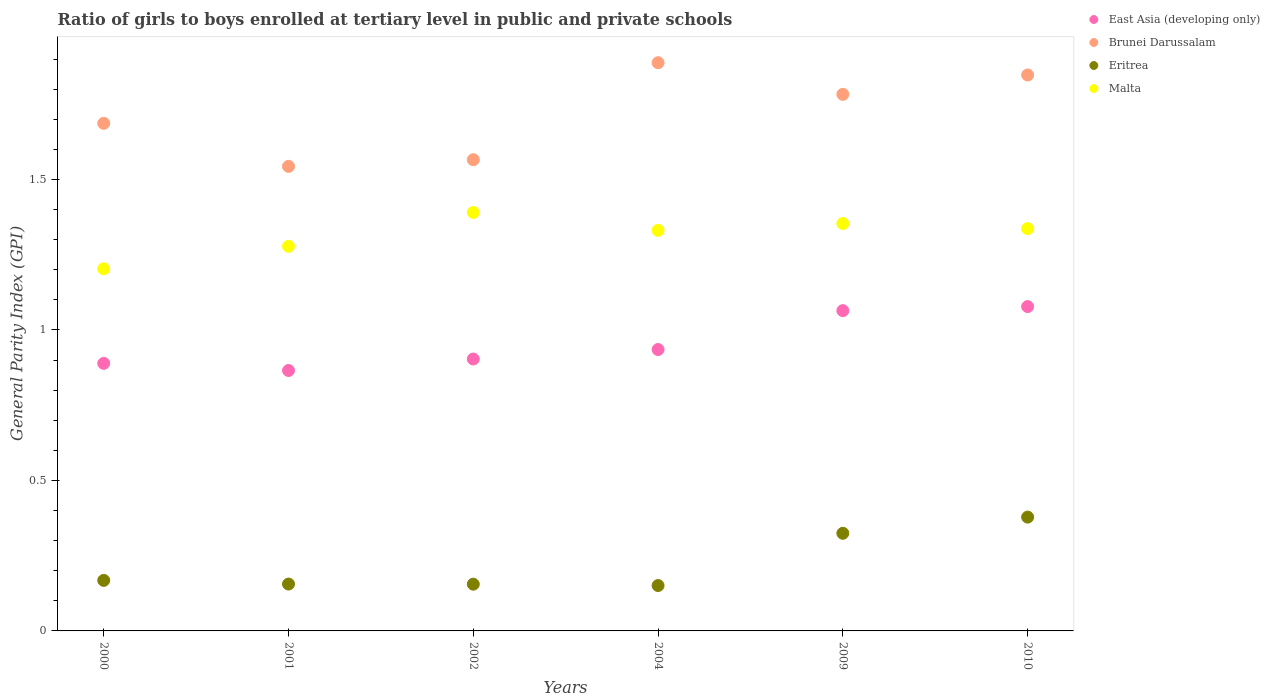Is the number of dotlines equal to the number of legend labels?
Keep it short and to the point. Yes. What is the general parity index in Brunei Darussalam in 2002?
Offer a terse response. 1.57. Across all years, what is the maximum general parity index in Malta?
Ensure brevity in your answer.  1.39. Across all years, what is the minimum general parity index in East Asia (developing only)?
Offer a very short reply. 0.87. In which year was the general parity index in Eritrea maximum?
Keep it short and to the point. 2010. What is the total general parity index in Malta in the graph?
Offer a very short reply. 7.89. What is the difference between the general parity index in Brunei Darussalam in 2001 and that in 2002?
Offer a very short reply. -0.02. What is the difference between the general parity index in East Asia (developing only) in 2002 and the general parity index in Eritrea in 2009?
Provide a succinct answer. 0.58. What is the average general parity index in Brunei Darussalam per year?
Offer a terse response. 1.72. In the year 2002, what is the difference between the general parity index in Brunei Darussalam and general parity index in Malta?
Keep it short and to the point. 0.18. In how many years, is the general parity index in East Asia (developing only) greater than 0.4?
Provide a succinct answer. 6. What is the ratio of the general parity index in Eritrea in 2004 to that in 2010?
Make the answer very short. 0.4. Is the difference between the general parity index in Brunei Darussalam in 2002 and 2004 greater than the difference between the general parity index in Malta in 2002 and 2004?
Keep it short and to the point. No. What is the difference between the highest and the second highest general parity index in Brunei Darussalam?
Your response must be concise. 0.04. What is the difference between the highest and the lowest general parity index in Malta?
Your answer should be very brief. 0.19. How many dotlines are there?
Your answer should be compact. 4. Does the graph contain grids?
Provide a short and direct response. No. What is the title of the graph?
Your answer should be compact. Ratio of girls to boys enrolled at tertiary level in public and private schools. What is the label or title of the Y-axis?
Your answer should be very brief. General Parity Index (GPI). What is the General Parity Index (GPI) of East Asia (developing only) in 2000?
Provide a succinct answer. 0.89. What is the General Parity Index (GPI) in Brunei Darussalam in 2000?
Keep it short and to the point. 1.69. What is the General Parity Index (GPI) of Eritrea in 2000?
Give a very brief answer. 0.17. What is the General Parity Index (GPI) of Malta in 2000?
Make the answer very short. 1.2. What is the General Parity Index (GPI) in East Asia (developing only) in 2001?
Keep it short and to the point. 0.87. What is the General Parity Index (GPI) in Brunei Darussalam in 2001?
Give a very brief answer. 1.54. What is the General Parity Index (GPI) of Eritrea in 2001?
Give a very brief answer. 0.16. What is the General Parity Index (GPI) of Malta in 2001?
Your response must be concise. 1.28. What is the General Parity Index (GPI) of East Asia (developing only) in 2002?
Your answer should be very brief. 0.9. What is the General Parity Index (GPI) in Brunei Darussalam in 2002?
Make the answer very short. 1.57. What is the General Parity Index (GPI) of Eritrea in 2002?
Offer a terse response. 0.16. What is the General Parity Index (GPI) in Malta in 2002?
Offer a terse response. 1.39. What is the General Parity Index (GPI) of East Asia (developing only) in 2004?
Your answer should be compact. 0.94. What is the General Parity Index (GPI) of Brunei Darussalam in 2004?
Make the answer very short. 1.89. What is the General Parity Index (GPI) of Eritrea in 2004?
Offer a terse response. 0.15. What is the General Parity Index (GPI) of Malta in 2004?
Your answer should be very brief. 1.33. What is the General Parity Index (GPI) in East Asia (developing only) in 2009?
Provide a short and direct response. 1.06. What is the General Parity Index (GPI) in Brunei Darussalam in 2009?
Provide a short and direct response. 1.78. What is the General Parity Index (GPI) of Eritrea in 2009?
Keep it short and to the point. 0.32. What is the General Parity Index (GPI) in Malta in 2009?
Make the answer very short. 1.35. What is the General Parity Index (GPI) in East Asia (developing only) in 2010?
Your answer should be very brief. 1.08. What is the General Parity Index (GPI) in Brunei Darussalam in 2010?
Your response must be concise. 1.85. What is the General Parity Index (GPI) of Eritrea in 2010?
Offer a terse response. 0.38. What is the General Parity Index (GPI) in Malta in 2010?
Offer a very short reply. 1.34. Across all years, what is the maximum General Parity Index (GPI) in East Asia (developing only)?
Your answer should be compact. 1.08. Across all years, what is the maximum General Parity Index (GPI) in Brunei Darussalam?
Keep it short and to the point. 1.89. Across all years, what is the maximum General Parity Index (GPI) of Eritrea?
Provide a short and direct response. 0.38. Across all years, what is the maximum General Parity Index (GPI) of Malta?
Keep it short and to the point. 1.39. Across all years, what is the minimum General Parity Index (GPI) of East Asia (developing only)?
Your answer should be compact. 0.87. Across all years, what is the minimum General Parity Index (GPI) in Brunei Darussalam?
Give a very brief answer. 1.54. Across all years, what is the minimum General Parity Index (GPI) of Eritrea?
Offer a very short reply. 0.15. Across all years, what is the minimum General Parity Index (GPI) in Malta?
Your answer should be very brief. 1.2. What is the total General Parity Index (GPI) in East Asia (developing only) in the graph?
Your response must be concise. 5.74. What is the total General Parity Index (GPI) of Brunei Darussalam in the graph?
Offer a very short reply. 10.32. What is the total General Parity Index (GPI) in Eritrea in the graph?
Your answer should be compact. 1.33. What is the total General Parity Index (GPI) of Malta in the graph?
Your answer should be compact. 7.89. What is the difference between the General Parity Index (GPI) of East Asia (developing only) in 2000 and that in 2001?
Make the answer very short. 0.02. What is the difference between the General Parity Index (GPI) of Brunei Darussalam in 2000 and that in 2001?
Offer a very short reply. 0.14. What is the difference between the General Parity Index (GPI) in Eritrea in 2000 and that in 2001?
Give a very brief answer. 0.01. What is the difference between the General Parity Index (GPI) in Malta in 2000 and that in 2001?
Make the answer very short. -0.07. What is the difference between the General Parity Index (GPI) of East Asia (developing only) in 2000 and that in 2002?
Provide a short and direct response. -0.01. What is the difference between the General Parity Index (GPI) of Brunei Darussalam in 2000 and that in 2002?
Your response must be concise. 0.12. What is the difference between the General Parity Index (GPI) of Eritrea in 2000 and that in 2002?
Provide a short and direct response. 0.01. What is the difference between the General Parity Index (GPI) in Malta in 2000 and that in 2002?
Ensure brevity in your answer.  -0.19. What is the difference between the General Parity Index (GPI) in East Asia (developing only) in 2000 and that in 2004?
Provide a succinct answer. -0.05. What is the difference between the General Parity Index (GPI) in Brunei Darussalam in 2000 and that in 2004?
Provide a short and direct response. -0.2. What is the difference between the General Parity Index (GPI) in Eritrea in 2000 and that in 2004?
Provide a short and direct response. 0.02. What is the difference between the General Parity Index (GPI) of Malta in 2000 and that in 2004?
Offer a terse response. -0.13. What is the difference between the General Parity Index (GPI) of East Asia (developing only) in 2000 and that in 2009?
Your answer should be very brief. -0.18. What is the difference between the General Parity Index (GPI) of Brunei Darussalam in 2000 and that in 2009?
Your answer should be very brief. -0.1. What is the difference between the General Parity Index (GPI) in Eritrea in 2000 and that in 2009?
Ensure brevity in your answer.  -0.16. What is the difference between the General Parity Index (GPI) of Malta in 2000 and that in 2009?
Give a very brief answer. -0.15. What is the difference between the General Parity Index (GPI) in East Asia (developing only) in 2000 and that in 2010?
Keep it short and to the point. -0.19. What is the difference between the General Parity Index (GPI) in Brunei Darussalam in 2000 and that in 2010?
Ensure brevity in your answer.  -0.16. What is the difference between the General Parity Index (GPI) in Eritrea in 2000 and that in 2010?
Your response must be concise. -0.21. What is the difference between the General Parity Index (GPI) in Malta in 2000 and that in 2010?
Offer a very short reply. -0.13. What is the difference between the General Parity Index (GPI) in East Asia (developing only) in 2001 and that in 2002?
Your response must be concise. -0.04. What is the difference between the General Parity Index (GPI) of Brunei Darussalam in 2001 and that in 2002?
Your answer should be very brief. -0.02. What is the difference between the General Parity Index (GPI) in Malta in 2001 and that in 2002?
Offer a terse response. -0.11. What is the difference between the General Parity Index (GPI) in East Asia (developing only) in 2001 and that in 2004?
Your response must be concise. -0.07. What is the difference between the General Parity Index (GPI) in Brunei Darussalam in 2001 and that in 2004?
Give a very brief answer. -0.34. What is the difference between the General Parity Index (GPI) in Eritrea in 2001 and that in 2004?
Offer a terse response. 0. What is the difference between the General Parity Index (GPI) in Malta in 2001 and that in 2004?
Keep it short and to the point. -0.05. What is the difference between the General Parity Index (GPI) in East Asia (developing only) in 2001 and that in 2009?
Provide a short and direct response. -0.2. What is the difference between the General Parity Index (GPI) in Brunei Darussalam in 2001 and that in 2009?
Provide a succinct answer. -0.24. What is the difference between the General Parity Index (GPI) of Eritrea in 2001 and that in 2009?
Your answer should be very brief. -0.17. What is the difference between the General Parity Index (GPI) of Malta in 2001 and that in 2009?
Provide a short and direct response. -0.08. What is the difference between the General Parity Index (GPI) of East Asia (developing only) in 2001 and that in 2010?
Your answer should be compact. -0.21. What is the difference between the General Parity Index (GPI) of Brunei Darussalam in 2001 and that in 2010?
Your answer should be compact. -0.3. What is the difference between the General Parity Index (GPI) in Eritrea in 2001 and that in 2010?
Provide a succinct answer. -0.22. What is the difference between the General Parity Index (GPI) of Malta in 2001 and that in 2010?
Your answer should be very brief. -0.06. What is the difference between the General Parity Index (GPI) of East Asia (developing only) in 2002 and that in 2004?
Keep it short and to the point. -0.03. What is the difference between the General Parity Index (GPI) in Brunei Darussalam in 2002 and that in 2004?
Provide a succinct answer. -0.32. What is the difference between the General Parity Index (GPI) in Eritrea in 2002 and that in 2004?
Your answer should be very brief. 0. What is the difference between the General Parity Index (GPI) of Malta in 2002 and that in 2004?
Your answer should be compact. 0.06. What is the difference between the General Parity Index (GPI) of East Asia (developing only) in 2002 and that in 2009?
Keep it short and to the point. -0.16. What is the difference between the General Parity Index (GPI) in Brunei Darussalam in 2002 and that in 2009?
Make the answer very short. -0.22. What is the difference between the General Parity Index (GPI) of Eritrea in 2002 and that in 2009?
Make the answer very short. -0.17. What is the difference between the General Parity Index (GPI) of Malta in 2002 and that in 2009?
Provide a short and direct response. 0.04. What is the difference between the General Parity Index (GPI) in East Asia (developing only) in 2002 and that in 2010?
Ensure brevity in your answer.  -0.17. What is the difference between the General Parity Index (GPI) of Brunei Darussalam in 2002 and that in 2010?
Provide a short and direct response. -0.28. What is the difference between the General Parity Index (GPI) in Eritrea in 2002 and that in 2010?
Your response must be concise. -0.22. What is the difference between the General Parity Index (GPI) in Malta in 2002 and that in 2010?
Give a very brief answer. 0.05. What is the difference between the General Parity Index (GPI) of East Asia (developing only) in 2004 and that in 2009?
Your answer should be very brief. -0.13. What is the difference between the General Parity Index (GPI) of Brunei Darussalam in 2004 and that in 2009?
Ensure brevity in your answer.  0.11. What is the difference between the General Parity Index (GPI) in Eritrea in 2004 and that in 2009?
Your answer should be very brief. -0.17. What is the difference between the General Parity Index (GPI) of Malta in 2004 and that in 2009?
Ensure brevity in your answer.  -0.02. What is the difference between the General Parity Index (GPI) of East Asia (developing only) in 2004 and that in 2010?
Your answer should be very brief. -0.14. What is the difference between the General Parity Index (GPI) in Brunei Darussalam in 2004 and that in 2010?
Your answer should be compact. 0.04. What is the difference between the General Parity Index (GPI) in Eritrea in 2004 and that in 2010?
Give a very brief answer. -0.23. What is the difference between the General Parity Index (GPI) of Malta in 2004 and that in 2010?
Make the answer very short. -0.01. What is the difference between the General Parity Index (GPI) in East Asia (developing only) in 2009 and that in 2010?
Ensure brevity in your answer.  -0.01. What is the difference between the General Parity Index (GPI) in Brunei Darussalam in 2009 and that in 2010?
Provide a succinct answer. -0.06. What is the difference between the General Parity Index (GPI) in Eritrea in 2009 and that in 2010?
Keep it short and to the point. -0.05. What is the difference between the General Parity Index (GPI) of Malta in 2009 and that in 2010?
Keep it short and to the point. 0.02. What is the difference between the General Parity Index (GPI) in East Asia (developing only) in 2000 and the General Parity Index (GPI) in Brunei Darussalam in 2001?
Provide a short and direct response. -0.65. What is the difference between the General Parity Index (GPI) in East Asia (developing only) in 2000 and the General Parity Index (GPI) in Eritrea in 2001?
Give a very brief answer. 0.73. What is the difference between the General Parity Index (GPI) in East Asia (developing only) in 2000 and the General Parity Index (GPI) in Malta in 2001?
Your response must be concise. -0.39. What is the difference between the General Parity Index (GPI) in Brunei Darussalam in 2000 and the General Parity Index (GPI) in Eritrea in 2001?
Provide a short and direct response. 1.53. What is the difference between the General Parity Index (GPI) in Brunei Darussalam in 2000 and the General Parity Index (GPI) in Malta in 2001?
Provide a short and direct response. 0.41. What is the difference between the General Parity Index (GPI) of Eritrea in 2000 and the General Parity Index (GPI) of Malta in 2001?
Your response must be concise. -1.11. What is the difference between the General Parity Index (GPI) of East Asia (developing only) in 2000 and the General Parity Index (GPI) of Brunei Darussalam in 2002?
Make the answer very short. -0.68. What is the difference between the General Parity Index (GPI) in East Asia (developing only) in 2000 and the General Parity Index (GPI) in Eritrea in 2002?
Your answer should be compact. 0.73. What is the difference between the General Parity Index (GPI) of East Asia (developing only) in 2000 and the General Parity Index (GPI) of Malta in 2002?
Your answer should be compact. -0.5. What is the difference between the General Parity Index (GPI) in Brunei Darussalam in 2000 and the General Parity Index (GPI) in Eritrea in 2002?
Your answer should be compact. 1.53. What is the difference between the General Parity Index (GPI) of Brunei Darussalam in 2000 and the General Parity Index (GPI) of Malta in 2002?
Keep it short and to the point. 0.3. What is the difference between the General Parity Index (GPI) in Eritrea in 2000 and the General Parity Index (GPI) in Malta in 2002?
Offer a very short reply. -1.22. What is the difference between the General Parity Index (GPI) in East Asia (developing only) in 2000 and the General Parity Index (GPI) in Brunei Darussalam in 2004?
Provide a succinct answer. -1. What is the difference between the General Parity Index (GPI) of East Asia (developing only) in 2000 and the General Parity Index (GPI) of Eritrea in 2004?
Ensure brevity in your answer.  0.74. What is the difference between the General Parity Index (GPI) of East Asia (developing only) in 2000 and the General Parity Index (GPI) of Malta in 2004?
Your answer should be very brief. -0.44. What is the difference between the General Parity Index (GPI) of Brunei Darussalam in 2000 and the General Parity Index (GPI) of Eritrea in 2004?
Provide a succinct answer. 1.54. What is the difference between the General Parity Index (GPI) of Brunei Darussalam in 2000 and the General Parity Index (GPI) of Malta in 2004?
Your answer should be very brief. 0.36. What is the difference between the General Parity Index (GPI) in Eritrea in 2000 and the General Parity Index (GPI) in Malta in 2004?
Give a very brief answer. -1.16. What is the difference between the General Parity Index (GPI) in East Asia (developing only) in 2000 and the General Parity Index (GPI) in Brunei Darussalam in 2009?
Provide a succinct answer. -0.89. What is the difference between the General Parity Index (GPI) in East Asia (developing only) in 2000 and the General Parity Index (GPI) in Eritrea in 2009?
Offer a very short reply. 0.56. What is the difference between the General Parity Index (GPI) of East Asia (developing only) in 2000 and the General Parity Index (GPI) of Malta in 2009?
Your answer should be very brief. -0.46. What is the difference between the General Parity Index (GPI) in Brunei Darussalam in 2000 and the General Parity Index (GPI) in Eritrea in 2009?
Offer a terse response. 1.36. What is the difference between the General Parity Index (GPI) in Brunei Darussalam in 2000 and the General Parity Index (GPI) in Malta in 2009?
Keep it short and to the point. 0.33. What is the difference between the General Parity Index (GPI) of Eritrea in 2000 and the General Parity Index (GPI) of Malta in 2009?
Provide a short and direct response. -1.19. What is the difference between the General Parity Index (GPI) of East Asia (developing only) in 2000 and the General Parity Index (GPI) of Brunei Darussalam in 2010?
Your answer should be very brief. -0.96. What is the difference between the General Parity Index (GPI) in East Asia (developing only) in 2000 and the General Parity Index (GPI) in Eritrea in 2010?
Offer a very short reply. 0.51. What is the difference between the General Parity Index (GPI) in East Asia (developing only) in 2000 and the General Parity Index (GPI) in Malta in 2010?
Keep it short and to the point. -0.45. What is the difference between the General Parity Index (GPI) of Brunei Darussalam in 2000 and the General Parity Index (GPI) of Eritrea in 2010?
Provide a short and direct response. 1.31. What is the difference between the General Parity Index (GPI) in Eritrea in 2000 and the General Parity Index (GPI) in Malta in 2010?
Offer a terse response. -1.17. What is the difference between the General Parity Index (GPI) of East Asia (developing only) in 2001 and the General Parity Index (GPI) of Brunei Darussalam in 2002?
Ensure brevity in your answer.  -0.7. What is the difference between the General Parity Index (GPI) of East Asia (developing only) in 2001 and the General Parity Index (GPI) of Eritrea in 2002?
Make the answer very short. 0.71. What is the difference between the General Parity Index (GPI) of East Asia (developing only) in 2001 and the General Parity Index (GPI) of Malta in 2002?
Offer a very short reply. -0.53. What is the difference between the General Parity Index (GPI) of Brunei Darussalam in 2001 and the General Parity Index (GPI) of Eritrea in 2002?
Provide a succinct answer. 1.39. What is the difference between the General Parity Index (GPI) in Brunei Darussalam in 2001 and the General Parity Index (GPI) in Malta in 2002?
Give a very brief answer. 0.15. What is the difference between the General Parity Index (GPI) of Eritrea in 2001 and the General Parity Index (GPI) of Malta in 2002?
Your response must be concise. -1.23. What is the difference between the General Parity Index (GPI) in East Asia (developing only) in 2001 and the General Parity Index (GPI) in Brunei Darussalam in 2004?
Your answer should be very brief. -1.02. What is the difference between the General Parity Index (GPI) in East Asia (developing only) in 2001 and the General Parity Index (GPI) in Eritrea in 2004?
Ensure brevity in your answer.  0.71. What is the difference between the General Parity Index (GPI) of East Asia (developing only) in 2001 and the General Parity Index (GPI) of Malta in 2004?
Keep it short and to the point. -0.47. What is the difference between the General Parity Index (GPI) in Brunei Darussalam in 2001 and the General Parity Index (GPI) in Eritrea in 2004?
Make the answer very short. 1.39. What is the difference between the General Parity Index (GPI) in Brunei Darussalam in 2001 and the General Parity Index (GPI) in Malta in 2004?
Ensure brevity in your answer.  0.21. What is the difference between the General Parity Index (GPI) of Eritrea in 2001 and the General Parity Index (GPI) of Malta in 2004?
Your response must be concise. -1.18. What is the difference between the General Parity Index (GPI) in East Asia (developing only) in 2001 and the General Parity Index (GPI) in Brunei Darussalam in 2009?
Provide a short and direct response. -0.92. What is the difference between the General Parity Index (GPI) in East Asia (developing only) in 2001 and the General Parity Index (GPI) in Eritrea in 2009?
Offer a terse response. 0.54. What is the difference between the General Parity Index (GPI) of East Asia (developing only) in 2001 and the General Parity Index (GPI) of Malta in 2009?
Keep it short and to the point. -0.49. What is the difference between the General Parity Index (GPI) in Brunei Darussalam in 2001 and the General Parity Index (GPI) in Eritrea in 2009?
Offer a very short reply. 1.22. What is the difference between the General Parity Index (GPI) of Brunei Darussalam in 2001 and the General Parity Index (GPI) of Malta in 2009?
Keep it short and to the point. 0.19. What is the difference between the General Parity Index (GPI) of Eritrea in 2001 and the General Parity Index (GPI) of Malta in 2009?
Provide a succinct answer. -1.2. What is the difference between the General Parity Index (GPI) of East Asia (developing only) in 2001 and the General Parity Index (GPI) of Brunei Darussalam in 2010?
Your answer should be very brief. -0.98. What is the difference between the General Parity Index (GPI) of East Asia (developing only) in 2001 and the General Parity Index (GPI) of Eritrea in 2010?
Make the answer very short. 0.49. What is the difference between the General Parity Index (GPI) in East Asia (developing only) in 2001 and the General Parity Index (GPI) in Malta in 2010?
Offer a terse response. -0.47. What is the difference between the General Parity Index (GPI) in Brunei Darussalam in 2001 and the General Parity Index (GPI) in Eritrea in 2010?
Your response must be concise. 1.17. What is the difference between the General Parity Index (GPI) in Brunei Darussalam in 2001 and the General Parity Index (GPI) in Malta in 2010?
Your response must be concise. 0.21. What is the difference between the General Parity Index (GPI) in Eritrea in 2001 and the General Parity Index (GPI) in Malta in 2010?
Offer a terse response. -1.18. What is the difference between the General Parity Index (GPI) in East Asia (developing only) in 2002 and the General Parity Index (GPI) in Brunei Darussalam in 2004?
Ensure brevity in your answer.  -0.98. What is the difference between the General Parity Index (GPI) of East Asia (developing only) in 2002 and the General Parity Index (GPI) of Eritrea in 2004?
Ensure brevity in your answer.  0.75. What is the difference between the General Parity Index (GPI) in East Asia (developing only) in 2002 and the General Parity Index (GPI) in Malta in 2004?
Offer a terse response. -0.43. What is the difference between the General Parity Index (GPI) of Brunei Darussalam in 2002 and the General Parity Index (GPI) of Eritrea in 2004?
Your answer should be compact. 1.42. What is the difference between the General Parity Index (GPI) in Brunei Darussalam in 2002 and the General Parity Index (GPI) in Malta in 2004?
Give a very brief answer. 0.23. What is the difference between the General Parity Index (GPI) in Eritrea in 2002 and the General Parity Index (GPI) in Malta in 2004?
Offer a terse response. -1.18. What is the difference between the General Parity Index (GPI) of East Asia (developing only) in 2002 and the General Parity Index (GPI) of Brunei Darussalam in 2009?
Offer a terse response. -0.88. What is the difference between the General Parity Index (GPI) of East Asia (developing only) in 2002 and the General Parity Index (GPI) of Eritrea in 2009?
Provide a short and direct response. 0.58. What is the difference between the General Parity Index (GPI) of East Asia (developing only) in 2002 and the General Parity Index (GPI) of Malta in 2009?
Offer a terse response. -0.45. What is the difference between the General Parity Index (GPI) in Brunei Darussalam in 2002 and the General Parity Index (GPI) in Eritrea in 2009?
Give a very brief answer. 1.24. What is the difference between the General Parity Index (GPI) in Brunei Darussalam in 2002 and the General Parity Index (GPI) in Malta in 2009?
Your answer should be compact. 0.21. What is the difference between the General Parity Index (GPI) in Eritrea in 2002 and the General Parity Index (GPI) in Malta in 2009?
Give a very brief answer. -1.2. What is the difference between the General Parity Index (GPI) in East Asia (developing only) in 2002 and the General Parity Index (GPI) in Brunei Darussalam in 2010?
Make the answer very short. -0.94. What is the difference between the General Parity Index (GPI) of East Asia (developing only) in 2002 and the General Parity Index (GPI) of Eritrea in 2010?
Make the answer very short. 0.53. What is the difference between the General Parity Index (GPI) in East Asia (developing only) in 2002 and the General Parity Index (GPI) in Malta in 2010?
Make the answer very short. -0.43. What is the difference between the General Parity Index (GPI) in Brunei Darussalam in 2002 and the General Parity Index (GPI) in Eritrea in 2010?
Your response must be concise. 1.19. What is the difference between the General Parity Index (GPI) in Brunei Darussalam in 2002 and the General Parity Index (GPI) in Malta in 2010?
Keep it short and to the point. 0.23. What is the difference between the General Parity Index (GPI) in Eritrea in 2002 and the General Parity Index (GPI) in Malta in 2010?
Provide a succinct answer. -1.18. What is the difference between the General Parity Index (GPI) of East Asia (developing only) in 2004 and the General Parity Index (GPI) of Brunei Darussalam in 2009?
Provide a succinct answer. -0.85. What is the difference between the General Parity Index (GPI) in East Asia (developing only) in 2004 and the General Parity Index (GPI) in Eritrea in 2009?
Offer a very short reply. 0.61. What is the difference between the General Parity Index (GPI) of East Asia (developing only) in 2004 and the General Parity Index (GPI) of Malta in 2009?
Keep it short and to the point. -0.42. What is the difference between the General Parity Index (GPI) in Brunei Darussalam in 2004 and the General Parity Index (GPI) in Eritrea in 2009?
Offer a terse response. 1.56. What is the difference between the General Parity Index (GPI) in Brunei Darussalam in 2004 and the General Parity Index (GPI) in Malta in 2009?
Offer a very short reply. 0.53. What is the difference between the General Parity Index (GPI) in Eritrea in 2004 and the General Parity Index (GPI) in Malta in 2009?
Provide a short and direct response. -1.2. What is the difference between the General Parity Index (GPI) in East Asia (developing only) in 2004 and the General Parity Index (GPI) in Brunei Darussalam in 2010?
Your answer should be very brief. -0.91. What is the difference between the General Parity Index (GPI) in East Asia (developing only) in 2004 and the General Parity Index (GPI) in Eritrea in 2010?
Offer a terse response. 0.56. What is the difference between the General Parity Index (GPI) in East Asia (developing only) in 2004 and the General Parity Index (GPI) in Malta in 2010?
Provide a short and direct response. -0.4. What is the difference between the General Parity Index (GPI) of Brunei Darussalam in 2004 and the General Parity Index (GPI) of Eritrea in 2010?
Ensure brevity in your answer.  1.51. What is the difference between the General Parity Index (GPI) in Brunei Darussalam in 2004 and the General Parity Index (GPI) in Malta in 2010?
Offer a very short reply. 0.55. What is the difference between the General Parity Index (GPI) in Eritrea in 2004 and the General Parity Index (GPI) in Malta in 2010?
Your response must be concise. -1.19. What is the difference between the General Parity Index (GPI) of East Asia (developing only) in 2009 and the General Parity Index (GPI) of Brunei Darussalam in 2010?
Your answer should be very brief. -0.78. What is the difference between the General Parity Index (GPI) of East Asia (developing only) in 2009 and the General Parity Index (GPI) of Eritrea in 2010?
Offer a terse response. 0.69. What is the difference between the General Parity Index (GPI) in East Asia (developing only) in 2009 and the General Parity Index (GPI) in Malta in 2010?
Offer a terse response. -0.27. What is the difference between the General Parity Index (GPI) of Brunei Darussalam in 2009 and the General Parity Index (GPI) of Eritrea in 2010?
Offer a very short reply. 1.4. What is the difference between the General Parity Index (GPI) in Brunei Darussalam in 2009 and the General Parity Index (GPI) in Malta in 2010?
Keep it short and to the point. 0.45. What is the difference between the General Parity Index (GPI) in Eritrea in 2009 and the General Parity Index (GPI) in Malta in 2010?
Your response must be concise. -1.01. What is the average General Parity Index (GPI) in East Asia (developing only) per year?
Keep it short and to the point. 0.96. What is the average General Parity Index (GPI) of Brunei Darussalam per year?
Provide a short and direct response. 1.72. What is the average General Parity Index (GPI) in Eritrea per year?
Keep it short and to the point. 0.22. What is the average General Parity Index (GPI) in Malta per year?
Your answer should be compact. 1.32. In the year 2000, what is the difference between the General Parity Index (GPI) of East Asia (developing only) and General Parity Index (GPI) of Brunei Darussalam?
Make the answer very short. -0.8. In the year 2000, what is the difference between the General Parity Index (GPI) of East Asia (developing only) and General Parity Index (GPI) of Eritrea?
Ensure brevity in your answer.  0.72. In the year 2000, what is the difference between the General Parity Index (GPI) of East Asia (developing only) and General Parity Index (GPI) of Malta?
Your answer should be compact. -0.31. In the year 2000, what is the difference between the General Parity Index (GPI) in Brunei Darussalam and General Parity Index (GPI) in Eritrea?
Give a very brief answer. 1.52. In the year 2000, what is the difference between the General Parity Index (GPI) in Brunei Darussalam and General Parity Index (GPI) in Malta?
Keep it short and to the point. 0.48. In the year 2000, what is the difference between the General Parity Index (GPI) in Eritrea and General Parity Index (GPI) in Malta?
Your answer should be compact. -1.04. In the year 2001, what is the difference between the General Parity Index (GPI) of East Asia (developing only) and General Parity Index (GPI) of Brunei Darussalam?
Give a very brief answer. -0.68. In the year 2001, what is the difference between the General Parity Index (GPI) of East Asia (developing only) and General Parity Index (GPI) of Eritrea?
Give a very brief answer. 0.71. In the year 2001, what is the difference between the General Parity Index (GPI) in East Asia (developing only) and General Parity Index (GPI) in Malta?
Keep it short and to the point. -0.41. In the year 2001, what is the difference between the General Parity Index (GPI) in Brunei Darussalam and General Parity Index (GPI) in Eritrea?
Make the answer very short. 1.39. In the year 2001, what is the difference between the General Parity Index (GPI) in Brunei Darussalam and General Parity Index (GPI) in Malta?
Offer a very short reply. 0.27. In the year 2001, what is the difference between the General Parity Index (GPI) in Eritrea and General Parity Index (GPI) in Malta?
Ensure brevity in your answer.  -1.12. In the year 2002, what is the difference between the General Parity Index (GPI) in East Asia (developing only) and General Parity Index (GPI) in Brunei Darussalam?
Provide a short and direct response. -0.66. In the year 2002, what is the difference between the General Parity Index (GPI) of East Asia (developing only) and General Parity Index (GPI) of Eritrea?
Offer a terse response. 0.75. In the year 2002, what is the difference between the General Parity Index (GPI) of East Asia (developing only) and General Parity Index (GPI) of Malta?
Make the answer very short. -0.49. In the year 2002, what is the difference between the General Parity Index (GPI) in Brunei Darussalam and General Parity Index (GPI) in Eritrea?
Your response must be concise. 1.41. In the year 2002, what is the difference between the General Parity Index (GPI) of Brunei Darussalam and General Parity Index (GPI) of Malta?
Ensure brevity in your answer.  0.18. In the year 2002, what is the difference between the General Parity Index (GPI) in Eritrea and General Parity Index (GPI) in Malta?
Give a very brief answer. -1.24. In the year 2004, what is the difference between the General Parity Index (GPI) of East Asia (developing only) and General Parity Index (GPI) of Brunei Darussalam?
Provide a succinct answer. -0.95. In the year 2004, what is the difference between the General Parity Index (GPI) of East Asia (developing only) and General Parity Index (GPI) of Eritrea?
Your response must be concise. 0.78. In the year 2004, what is the difference between the General Parity Index (GPI) of East Asia (developing only) and General Parity Index (GPI) of Malta?
Offer a very short reply. -0.4. In the year 2004, what is the difference between the General Parity Index (GPI) in Brunei Darussalam and General Parity Index (GPI) in Eritrea?
Offer a very short reply. 1.74. In the year 2004, what is the difference between the General Parity Index (GPI) in Brunei Darussalam and General Parity Index (GPI) in Malta?
Your answer should be very brief. 0.56. In the year 2004, what is the difference between the General Parity Index (GPI) of Eritrea and General Parity Index (GPI) of Malta?
Keep it short and to the point. -1.18. In the year 2009, what is the difference between the General Parity Index (GPI) of East Asia (developing only) and General Parity Index (GPI) of Brunei Darussalam?
Offer a very short reply. -0.72. In the year 2009, what is the difference between the General Parity Index (GPI) in East Asia (developing only) and General Parity Index (GPI) in Eritrea?
Your answer should be very brief. 0.74. In the year 2009, what is the difference between the General Parity Index (GPI) in East Asia (developing only) and General Parity Index (GPI) in Malta?
Ensure brevity in your answer.  -0.29. In the year 2009, what is the difference between the General Parity Index (GPI) in Brunei Darussalam and General Parity Index (GPI) in Eritrea?
Your answer should be compact. 1.46. In the year 2009, what is the difference between the General Parity Index (GPI) of Brunei Darussalam and General Parity Index (GPI) of Malta?
Provide a short and direct response. 0.43. In the year 2009, what is the difference between the General Parity Index (GPI) in Eritrea and General Parity Index (GPI) in Malta?
Ensure brevity in your answer.  -1.03. In the year 2010, what is the difference between the General Parity Index (GPI) of East Asia (developing only) and General Parity Index (GPI) of Brunei Darussalam?
Your response must be concise. -0.77. In the year 2010, what is the difference between the General Parity Index (GPI) of East Asia (developing only) and General Parity Index (GPI) of Eritrea?
Offer a terse response. 0.7. In the year 2010, what is the difference between the General Parity Index (GPI) of East Asia (developing only) and General Parity Index (GPI) of Malta?
Give a very brief answer. -0.26. In the year 2010, what is the difference between the General Parity Index (GPI) of Brunei Darussalam and General Parity Index (GPI) of Eritrea?
Your answer should be compact. 1.47. In the year 2010, what is the difference between the General Parity Index (GPI) in Brunei Darussalam and General Parity Index (GPI) in Malta?
Offer a very short reply. 0.51. In the year 2010, what is the difference between the General Parity Index (GPI) in Eritrea and General Parity Index (GPI) in Malta?
Give a very brief answer. -0.96. What is the ratio of the General Parity Index (GPI) in East Asia (developing only) in 2000 to that in 2001?
Offer a very short reply. 1.03. What is the ratio of the General Parity Index (GPI) of Brunei Darussalam in 2000 to that in 2001?
Give a very brief answer. 1.09. What is the ratio of the General Parity Index (GPI) of Eritrea in 2000 to that in 2001?
Provide a succinct answer. 1.08. What is the ratio of the General Parity Index (GPI) of Malta in 2000 to that in 2001?
Your answer should be very brief. 0.94. What is the ratio of the General Parity Index (GPI) in Brunei Darussalam in 2000 to that in 2002?
Offer a terse response. 1.08. What is the ratio of the General Parity Index (GPI) in Eritrea in 2000 to that in 2002?
Give a very brief answer. 1.08. What is the ratio of the General Parity Index (GPI) of Malta in 2000 to that in 2002?
Your answer should be very brief. 0.87. What is the ratio of the General Parity Index (GPI) in East Asia (developing only) in 2000 to that in 2004?
Provide a short and direct response. 0.95. What is the ratio of the General Parity Index (GPI) in Brunei Darussalam in 2000 to that in 2004?
Offer a very short reply. 0.89. What is the ratio of the General Parity Index (GPI) in Eritrea in 2000 to that in 2004?
Your response must be concise. 1.11. What is the ratio of the General Parity Index (GPI) in Malta in 2000 to that in 2004?
Offer a very short reply. 0.9. What is the ratio of the General Parity Index (GPI) in East Asia (developing only) in 2000 to that in 2009?
Provide a succinct answer. 0.84. What is the ratio of the General Parity Index (GPI) in Brunei Darussalam in 2000 to that in 2009?
Give a very brief answer. 0.95. What is the ratio of the General Parity Index (GPI) of Eritrea in 2000 to that in 2009?
Ensure brevity in your answer.  0.52. What is the ratio of the General Parity Index (GPI) of Malta in 2000 to that in 2009?
Offer a very short reply. 0.89. What is the ratio of the General Parity Index (GPI) of East Asia (developing only) in 2000 to that in 2010?
Your response must be concise. 0.82. What is the ratio of the General Parity Index (GPI) of Brunei Darussalam in 2000 to that in 2010?
Make the answer very short. 0.91. What is the ratio of the General Parity Index (GPI) in Eritrea in 2000 to that in 2010?
Ensure brevity in your answer.  0.44. What is the ratio of the General Parity Index (GPI) of Malta in 2000 to that in 2010?
Provide a short and direct response. 0.9. What is the ratio of the General Parity Index (GPI) in East Asia (developing only) in 2001 to that in 2002?
Ensure brevity in your answer.  0.96. What is the ratio of the General Parity Index (GPI) of Brunei Darussalam in 2001 to that in 2002?
Provide a short and direct response. 0.99. What is the ratio of the General Parity Index (GPI) of Malta in 2001 to that in 2002?
Keep it short and to the point. 0.92. What is the ratio of the General Parity Index (GPI) in East Asia (developing only) in 2001 to that in 2004?
Your answer should be very brief. 0.93. What is the ratio of the General Parity Index (GPI) in Brunei Darussalam in 2001 to that in 2004?
Make the answer very short. 0.82. What is the ratio of the General Parity Index (GPI) of Eritrea in 2001 to that in 2004?
Your answer should be compact. 1.03. What is the ratio of the General Parity Index (GPI) in Malta in 2001 to that in 2004?
Ensure brevity in your answer.  0.96. What is the ratio of the General Parity Index (GPI) of East Asia (developing only) in 2001 to that in 2009?
Ensure brevity in your answer.  0.81. What is the ratio of the General Parity Index (GPI) of Brunei Darussalam in 2001 to that in 2009?
Provide a succinct answer. 0.87. What is the ratio of the General Parity Index (GPI) in Eritrea in 2001 to that in 2009?
Offer a terse response. 0.48. What is the ratio of the General Parity Index (GPI) of Malta in 2001 to that in 2009?
Offer a terse response. 0.94. What is the ratio of the General Parity Index (GPI) of East Asia (developing only) in 2001 to that in 2010?
Offer a terse response. 0.8. What is the ratio of the General Parity Index (GPI) in Brunei Darussalam in 2001 to that in 2010?
Make the answer very short. 0.84. What is the ratio of the General Parity Index (GPI) of Eritrea in 2001 to that in 2010?
Your answer should be very brief. 0.41. What is the ratio of the General Parity Index (GPI) in Malta in 2001 to that in 2010?
Offer a very short reply. 0.96. What is the ratio of the General Parity Index (GPI) in East Asia (developing only) in 2002 to that in 2004?
Your answer should be very brief. 0.97. What is the ratio of the General Parity Index (GPI) of Brunei Darussalam in 2002 to that in 2004?
Your answer should be very brief. 0.83. What is the ratio of the General Parity Index (GPI) of Eritrea in 2002 to that in 2004?
Make the answer very short. 1.03. What is the ratio of the General Parity Index (GPI) of Malta in 2002 to that in 2004?
Provide a succinct answer. 1.04. What is the ratio of the General Parity Index (GPI) in East Asia (developing only) in 2002 to that in 2009?
Ensure brevity in your answer.  0.85. What is the ratio of the General Parity Index (GPI) of Brunei Darussalam in 2002 to that in 2009?
Ensure brevity in your answer.  0.88. What is the ratio of the General Parity Index (GPI) in Eritrea in 2002 to that in 2009?
Make the answer very short. 0.48. What is the ratio of the General Parity Index (GPI) of Malta in 2002 to that in 2009?
Ensure brevity in your answer.  1.03. What is the ratio of the General Parity Index (GPI) of East Asia (developing only) in 2002 to that in 2010?
Offer a terse response. 0.84. What is the ratio of the General Parity Index (GPI) in Brunei Darussalam in 2002 to that in 2010?
Keep it short and to the point. 0.85. What is the ratio of the General Parity Index (GPI) of Eritrea in 2002 to that in 2010?
Your response must be concise. 0.41. What is the ratio of the General Parity Index (GPI) in Malta in 2002 to that in 2010?
Offer a very short reply. 1.04. What is the ratio of the General Parity Index (GPI) of East Asia (developing only) in 2004 to that in 2009?
Ensure brevity in your answer.  0.88. What is the ratio of the General Parity Index (GPI) of Brunei Darussalam in 2004 to that in 2009?
Give a very brief answer. 1.06. What is the ratio of the General Parity Index (GPI) of Eritrea in 2004 to that in 2009?
Make the answer very short. 0.46. What is the ratio of the General Parity Index (GPI) in Malta in 2004 to that in 2009?
Keep it short and to the point. 0.98. What is the ratio of the General Parity Index (GPI) of East Asia (developing only) in 2004 to that in 2010?
Make the answer very short. 0.87. What is the ratio of the General Parity Index (GPI) of Brunei Darussalam in 2004 to that in 2010?
Your answer should be very brief. 1.02. What is the ratio of the General Parity Index (GPI) in Eritrea in 2004 to that in 2010?
Offer a terse response. 0.4. What is the ratio of the General Parity Index (GPI) in East Asia (developing only) in 2009 to that in 2010?
Your response must be concise. 0.99. What is the ratio of the General Parity Index (GPI) of Brunei Darussalam in 2009 to that in 2010?
Keep it short and to the point. 0.97. What is the ratio of the General Parity Index (GPI) of Eritrea in 2009 to that in 2010?
Your answer should be very brief. 0.86. What is the ratio of the General Parity Index (GPI) of Malta in 2009 to that in 2010?
Give a very brief answer. 1.01. What is the difference between the highest and the second highest General Parity Index (GPI) of East Asia (developing only)?
Offer a very short reply. 0.01. What is the difference between the highest and the second highest General Parity Index (GPI) of Brunei Darussalam?
Give a very brief answer. 0.04. What is the difference between the highest and the second highest General Parity Index (GPI) of Eritrea?
Make the answer very short. 0.05. What is the difference between the highest and the second highest General Parity Index (GPI) of Malta?
Keep it short and to the point. 0.04. What is the difference between the highest and the lowest General Parity Index (GPI) in East Asia (developing only)?
Provide a succinct answer. 0.21. What is the difference between the highest and the lowest General Parity Index (GPI) of Brunei Darussalam?
Provide a short and direct response. 0.34. What is the difference between the highest and the lowest General Parity Index (GPI) in Eritrea?
Your response must be concise. 0.23. What is the difference between the highest and the lowest General Parity Index (GPI) of Malta?
Ensure brevity in your answer.  0.19. 